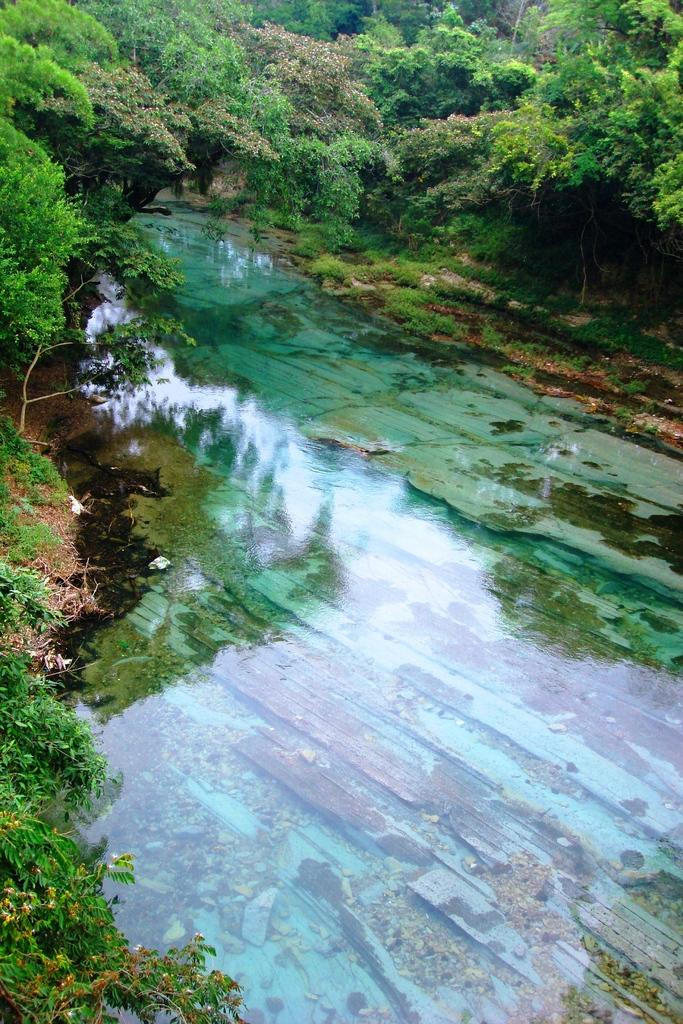What is the main feature in the center of the image? There is a pond in the center of the image. What type of vegetation can be seen on the right side of the image? There are trees on the right side of the image. What type of vegetation can be seen on the left side of the image? There are trees on the left side of the image. Is there a mountain visible in the image? No, there is no mountain present in the image. Can you see a volcano erupting in the image? No, there is no volcano present in the image. 